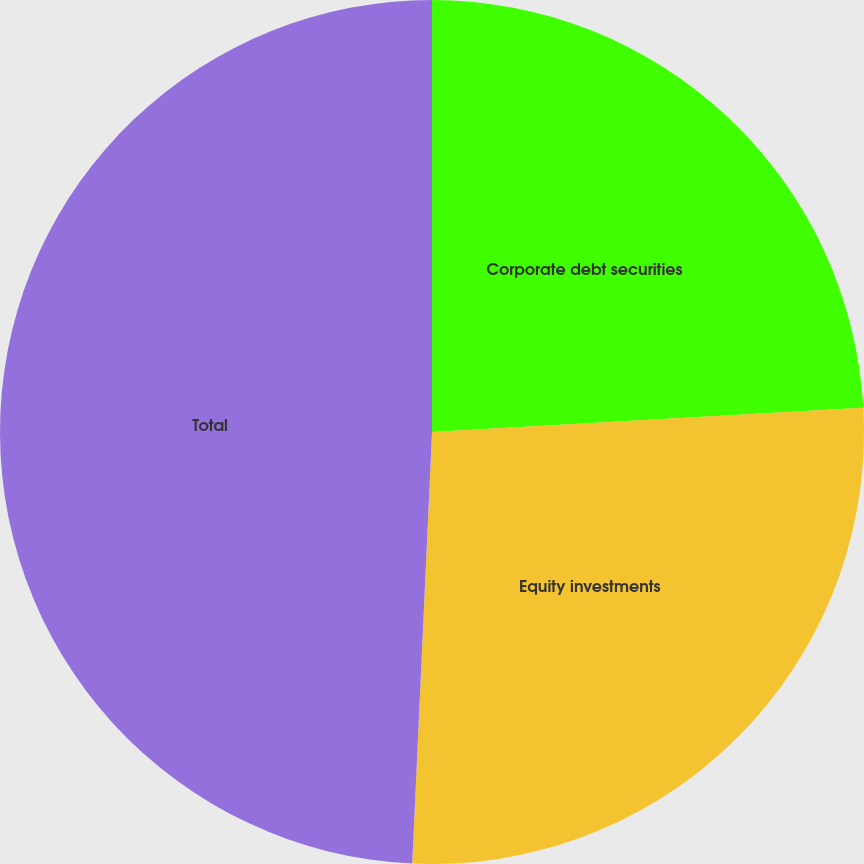Convert chart to OTSL. <chart><loc_0><loc_0><loc_500><loc_500><pie_chart><fcel>Corporate debt securities<fcel>Equity investments<fcel>Total<nl><fcel>24.11%<fcel>26.62%<fcel>49.27%<nl></chart> 